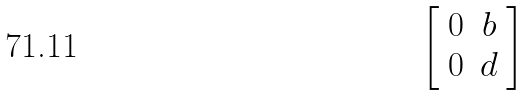<formula> <loc_0><loc_0><loc_500><loc_500>\left [ \begin{array} { c c } 0 & b \\ 0 & d \end{array} \right ]</formula> 